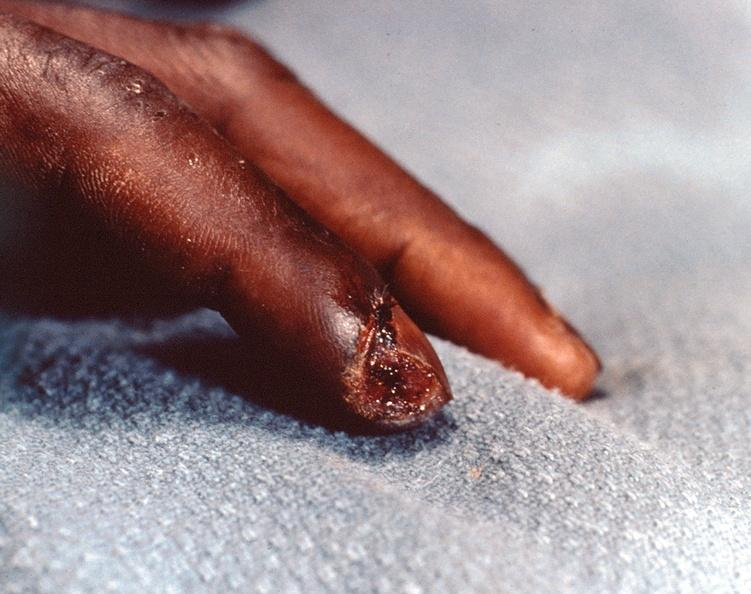re extremities present?
Answer the question using a single word or phrase. Yes 